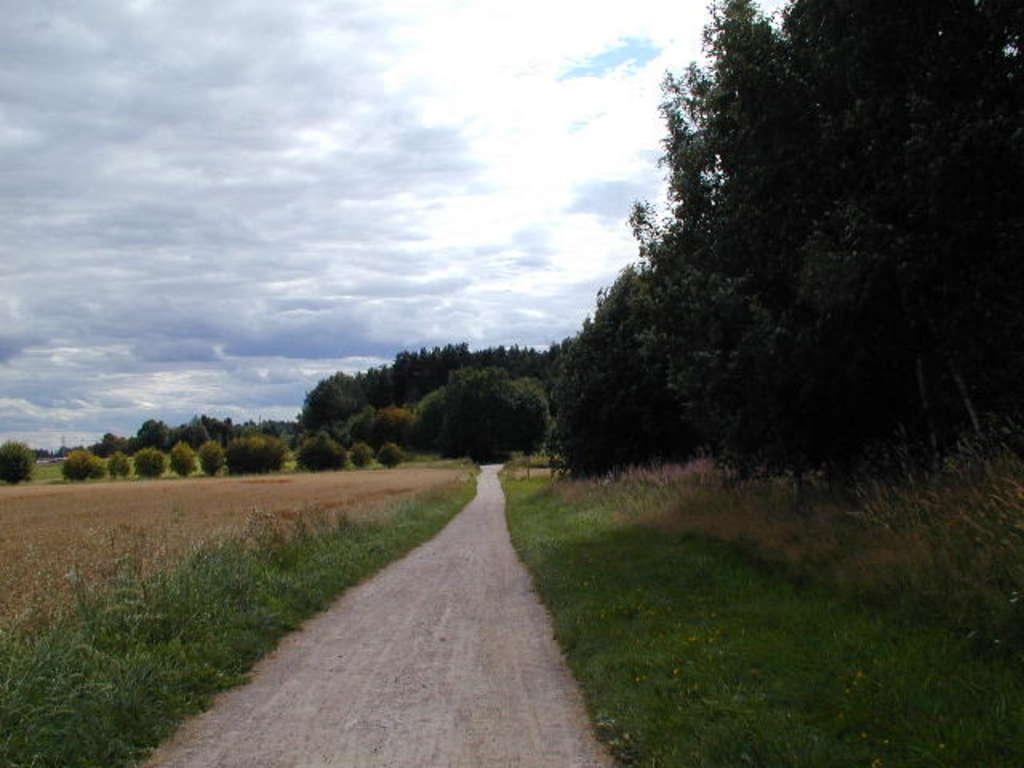What type of vegetation can be seen in the image? There are trees and plants in the image. What is located at the bottom of the image? There is a path at the bottom of the image. What can be seen in the sky in the image? There are clouds in the sky. What type of print can be seen on the queen's dress in the image? There is no queen or dress present in the image; it features trees, plants, a path, and clouds. 